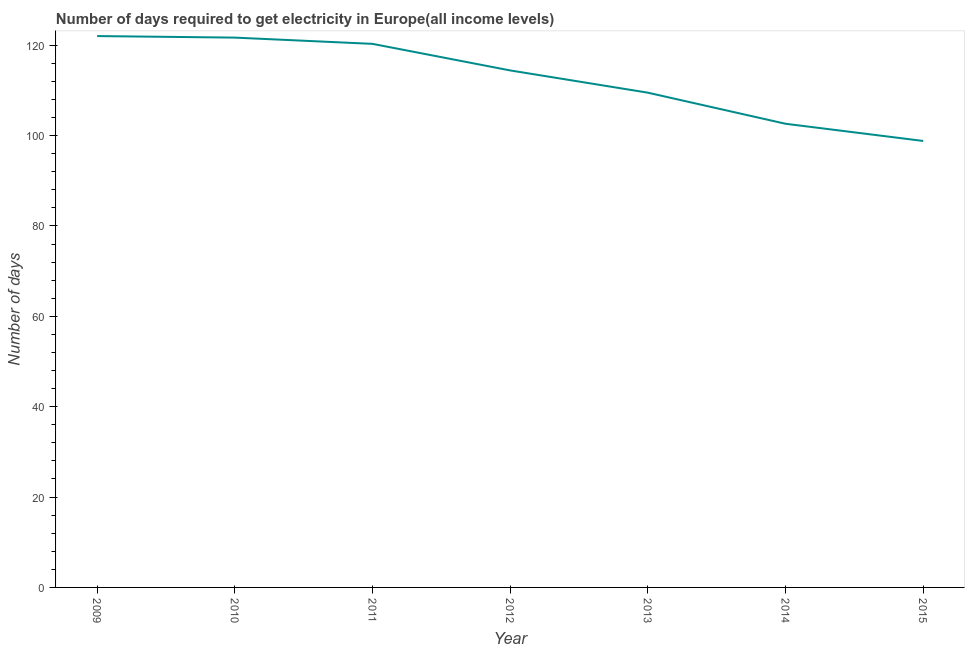What is the time to get electricity in 2015?
Provide a short and direct response. 98.81. Across all years, what is the maximum time to get electricity?
Your answer should be compact. 122.02. Across all years, what is the minimum time to get electricity?
Keep it short and to the point. 98.81. In which year was the time to get electricity maximum?
Offer a terse response. 2009. In which year was the time to get electricity minimum?
Offer a very short reply. 2015. What is the sum of the time to get electricity?
Your answer should be compact. 789.33. What is the difference between the time to get electricity in 2011 and 2015?
Provide a succinct answer. 21.49. What is the average time to get electricity per year?
Your answer should be compact. 112.76. What is the median time to get electricity?
Offer a very short reply. 114.42. Do a majority of the years between 2011 and 2014 (inclusive) have time to get electricity greater than 24 ?
Provide a succinct answer. Yes. What is the ratio of the time to get electricity in 2010 to that in 2011?
Give a very brief answer. 1.01. Is the time to get electricity in 2010 less than that in 2012?
Keep it short and to the point. No. What is the difference between the highest and the second highest time to get electricity?
Offer a very short reply. 0.34. Is the sum of the time to get electricity in 2009 and 2013 greater than the maximum time to get electricity across all years?
Your answer should be very brief. Yes. What is the difference between the highest and the lowest time to get electricity?
Your answer should be compact. 23.22. In how many years, is the time to get electricity greater than the average time to get electricity taken over all years?
Offer a terse response. 4. How many lines are there?
Give a very brief answer. 1. How many years are there in the graph?
Give a very brief answer. 7. What is the difference between two consecutive major ticks on the Y-axis?
Ensure brevity in your answer.  20. Are the values on the major ticks of Y-axis written in scientific E-notation?
Your answer should be very brief. No. Does the graph contain any zero values?
Make the answer very short. No. What is the title of the graph?
Your answer should be compact. Number of days required to get electricity in Europe(all income levels). What is the label or title of the X-axis?
Your answer should be very brief. Year. What is the label or title of the Y-axis?
Keep it short and to the point. Number of days. What is the Number of days in 2009?
Give a very brief answer. 122.02. What is the Number of days of 2010?
Your response must be concise. 121.68. What is the Number of days of 2011?
Ensure brevity in your answer.  120.3. What is the Number of days in 2012?
Give a very brief answer. 114.42. What is the Number of days of 2013?
Make the answer very short. 109.49. What is the Number of days in 2014?
Your response must be concise. 102.62. What is the Number of days in 2015?
Provide a short and direct response. 98.81. What is the difference between the Number of days in 2009 and 2010?
Your response must be concise. 0.34. What is the difference between the Number of days in 2009 and 2011?
Provide a succinct answer. 1.72. What is the difference between the Number of days in 2009 and 2012?
Your answer should be very brief. 7.6. What is the difference between the Number of days in 2009 and 2013?
Provide a succinct answer. 12.53. What is the difference between the Number of days in 2009 and 2014?
Your response must be concise. 19.4. What is the difference between the Number of days in 2009 and 2015?
Your response must be concise. 23.22. What is the difference between the Number of days in 2010 and 2011?
Provide a short and direct response. 1.38. What is the difference between the Number of days in 2010 and 2012?
Your answer should be very brief. 7.26. What is the difference between the Number of days in 2010 and 2013?
Provide a succinct answer. 12.19. What is the difference between the Number of days in 2010 and 2014?
Your answer should be very brief. 19.06. What is the difference between the Number of days in 2010 and 2015?
Offer a terse response. 22.87. What is the difference between the Number of days in 2011 and 2012?
Your answer should be very brief. 5.88. What is the difference between the Number of days in 2011 and 2013?
Your answer should be compact. 10.8. What is the difference between the Number of days in 2011 and 2014?
Give a very brief answer. 17.68. What is the difference between the Number of days in 2011 and 2015?
Keep it short and to the point. 21.49. What is the difference between the Number of days in 2012 and 2013?
Your answer should be compact. 4.92. What is the difference between the Number of days in 2012 and 2014?
Give a very brief answer. 11.8. What is the difference between the Number of days in 2012 and 2015?
Your answer should be very brief. 15.61. What is the difference between the Number of days in 2013 and 2014?
Your response must be concise. 6.88. What is the difference between the Number of days in 2013 and 2015?
Provide a short and direct response. 10.69. What is the difference between the Number of days in 2014 and 2015?
Offer a terse response. 3.81. What is the ratio of the Number of days in 2009 to that in 2010?
Give a very brief answer. 1. What is the ratio of the Number of days in 2009 to that in 2012?
Your answer should be very brief. 1.07. What is the ratio of the Number of days in 2009 to that in 2013?
Make the answer very short. 1.11. What is the ratio of the Number of days in 2009 to that in 2014?
Provide a succinct answer. 1.19. What is the ratio of the Number of days in 2009 to that in 2015?
Keep it short and to the point. 1.24. What is the ratio of the Number of days in 2010 to that in 2011?
Ensure brevity in your answer.  1.01. What is the ratio of the Number of days in 2010 to that in 2012?
Provide a succinct answer. 1.06. What is the ratio of the Number of days in 2010 to that in 2013?
Keep it short and to the point. 1.11. What is the ratio of the Number of days in 2010 to that in 2014?
Ensure brevity in your answer.  1.19. What is the ratio of the Number of days in 2010 to that in 2015?
Provide a short and direct response. 1.23. What is the ratio of the Number of days in 2011 to that in 2012?
Provide a short and direct response. 1.05. What is the ratio of the Number of days in 2011 to that in 2013?
Your response must be concise. 1.1. What is the ratio of the Number of days in 2011 to that in 2014?
Ensure brevity in your answer.  1.17. What is the ratio of the Number of days in 2011 to that in 2015?
Ensure brevity in your answer.  1.22. What is the ratio of the Number of days in 2012 to that in 2013?
Your answer should be compact. 1.04. What is the ratio of the Number of days in 2012 to that in 2014?
Your response must be concise. 1.11. What is the ratio of the Number of days in 2012 to that in 2015?
Provide a short and direct response. 1.16. What is the ratio of the Number of days in 2013 to that in 2014?
Make the answer very short. 1.07. What is the ratio of the Number of days in 2013 to that in 2015?
Make the answer very short. 1.11. What is the ratio of the Number of days in 2014 to that in 2015?
Keep it short and to the point. 1.04. 